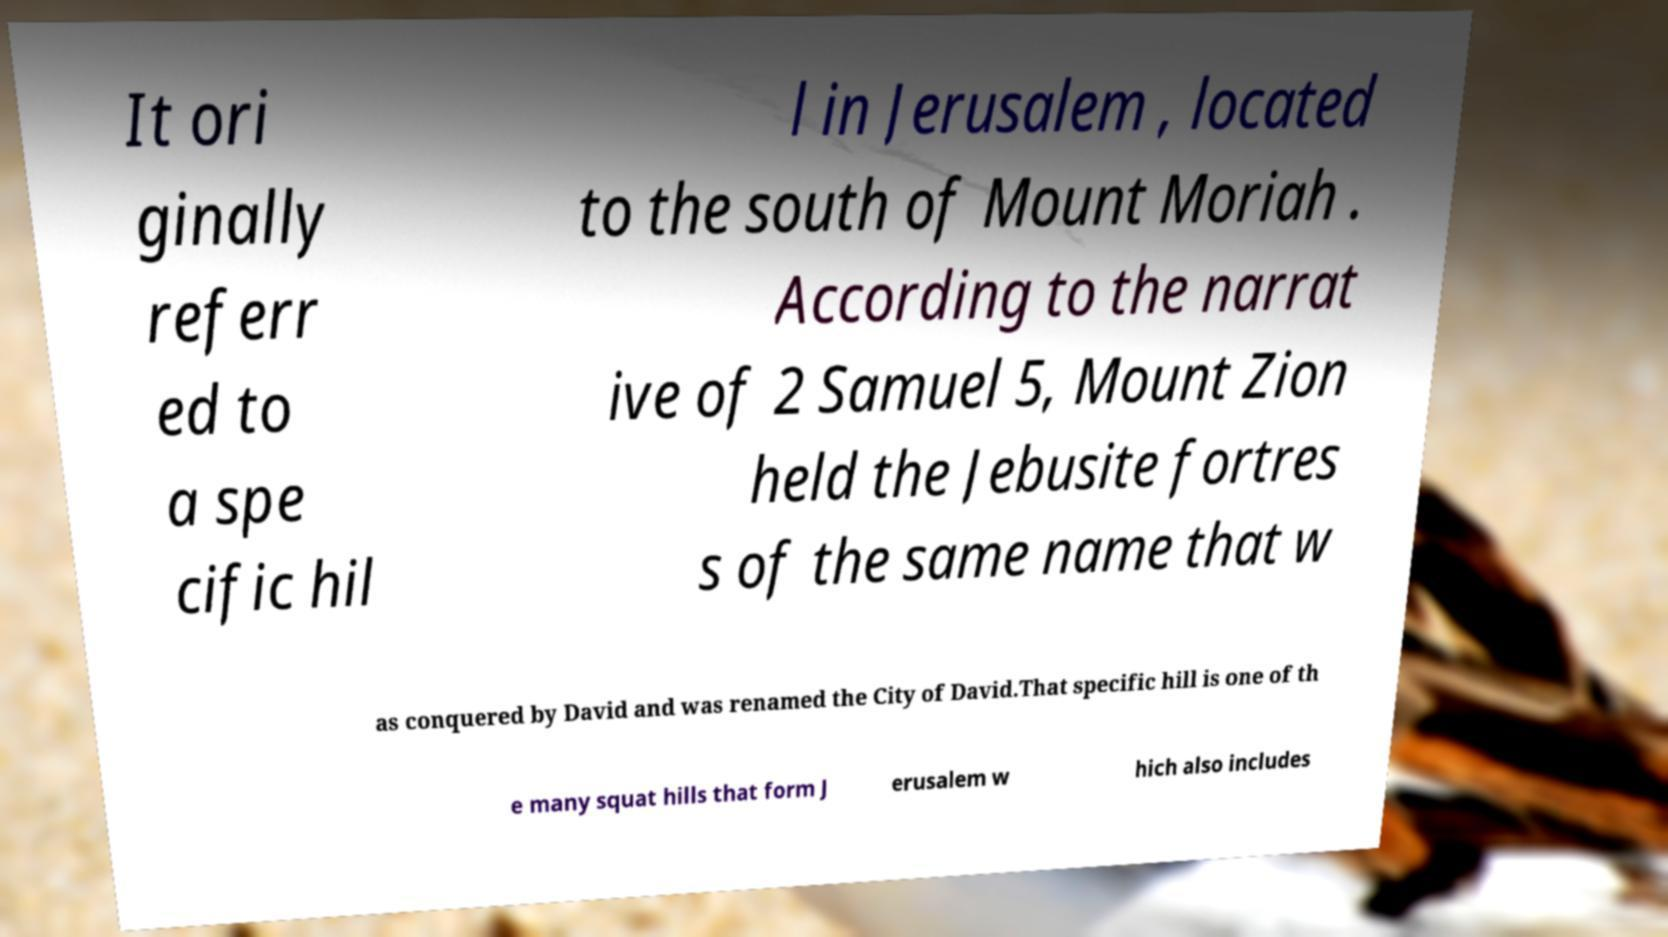There's text embedded in this image that I need extracted. Can you transcribe it verbatim? It ori ginally referr ed to a spe cific hil l in Jerusalem , located to the south of Mount Moriah . According to the narrat ive of 2 Samuel 5, Mount Zion held the Jebusite fortres s of the same name that w as conquered by David and was renamed the City of David.That specific hill is one of th e many squat hills that form J erusalem w hich also includes 